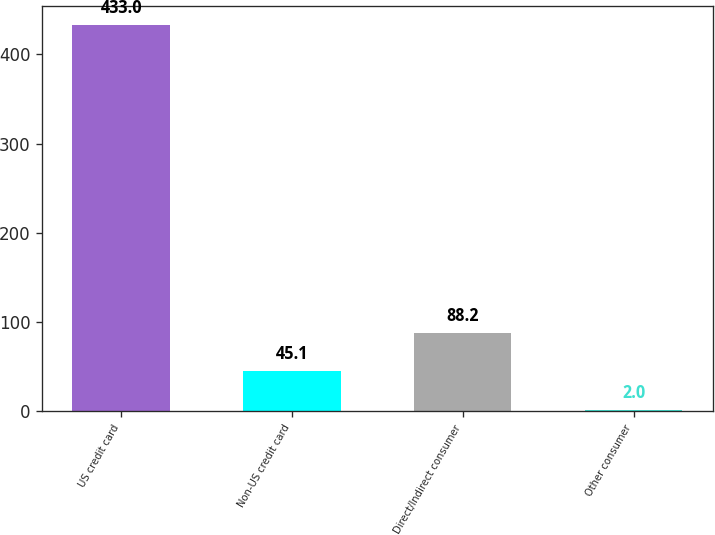Convert chart. <chart><loc_0><loc_0><loc_500><loc_500><bar_chart><fcel>US credit card<fcel>Non-US credit card<fcel>Direct/Indirect consumer<fcel>Other consumer<nl><fcel>433<fcel>45.1<fcel>88.2<fcel>2<nl></chart> 